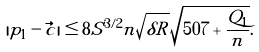Convert formula to latex. <formula><loc_0><loc_0><loc_500><loc_500>| p _ { 1 } - \vec { c } | \leq 8 S ^ { 3 / 2 } n \sqrt { \delta R } \sqrt { 5 0 7 + \frac { Q _ { 1 } } { n } } .</formula> 